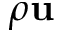<formula> <loc_0><loc_0><loc_500><loc_500>\rho u</formula> 